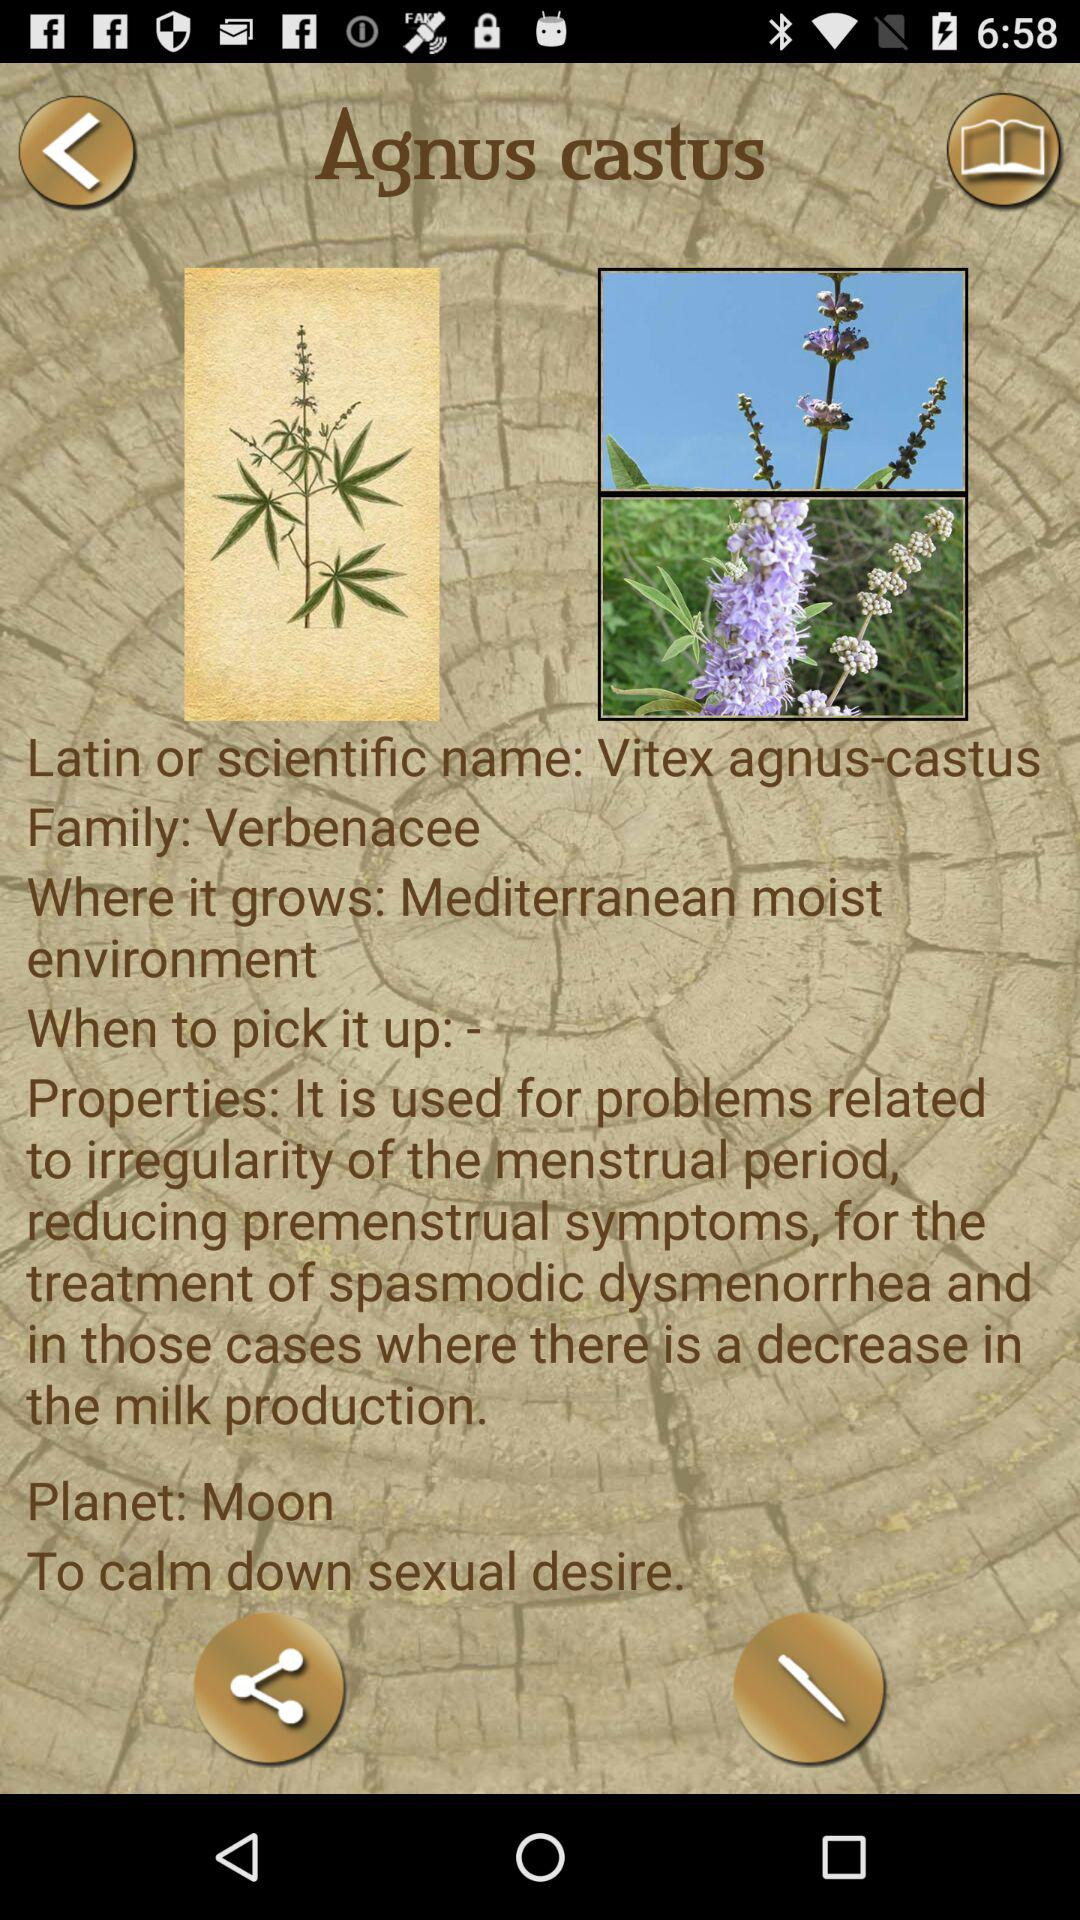What family does Agnus castus belong to? The family is "Verbenacee". 